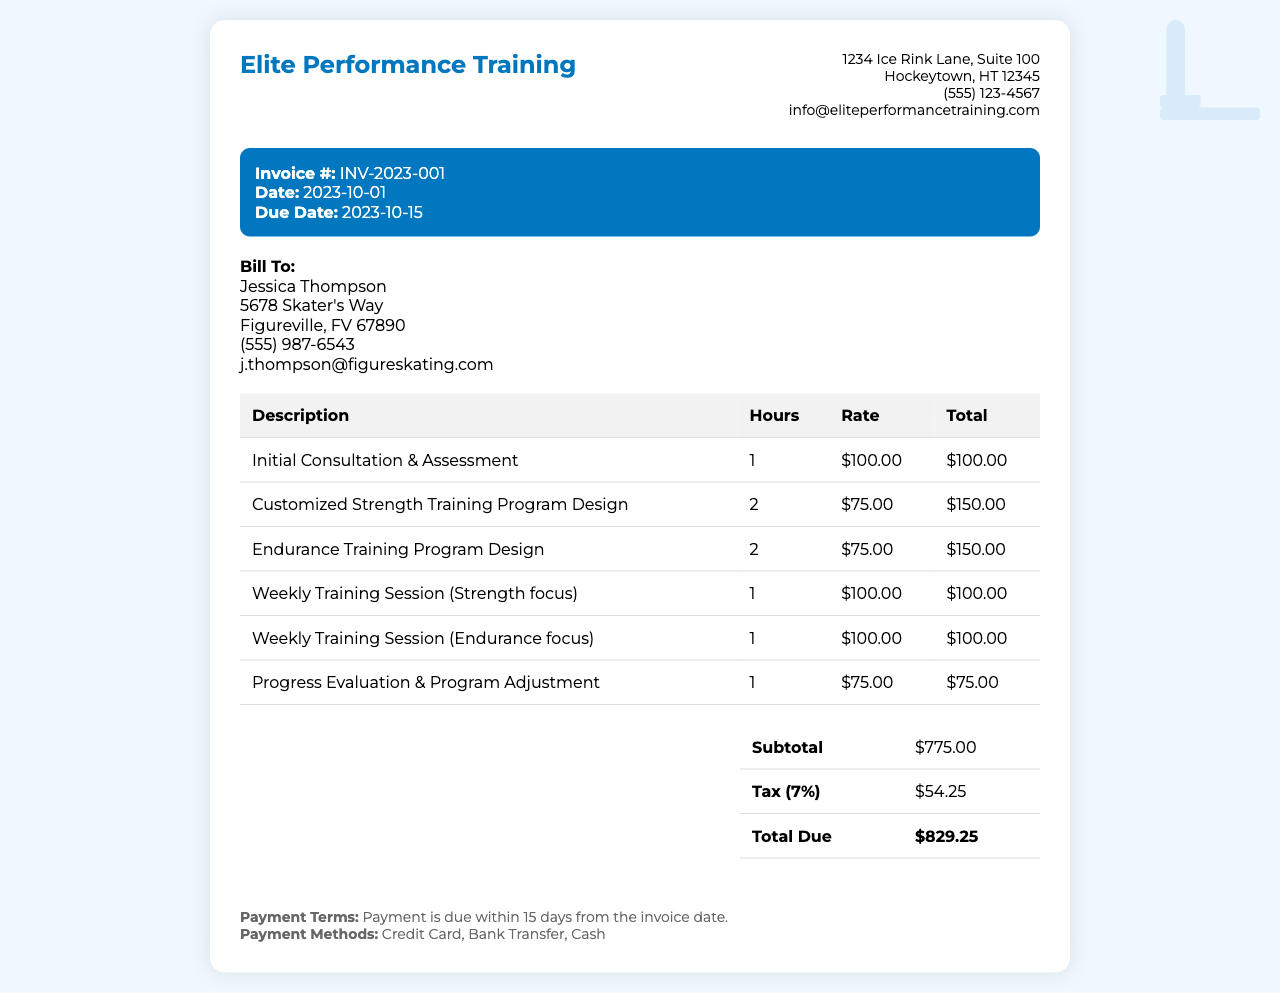What is the invoice number? The invoice number is located in the invoice details section, which identifies the specific invoice issued.
Answer: INV-2023-001 Who is the client? The client's name is provided in the client information section, which indicates who is being billed.
Answer: Jessica Thompson What is the total due amount? The total due amount is found in the summary table, which provides the final amount owed by the client including any taxes.
Answer: $829.25 What service has the highest hourly rate? The service with the highest hourly rate can be identified in the table of services based on individual rates per hour.
Answer: Initial Consultation & Assessment How many hours are billed for the Endurance Training Program Design? The number of hours for which the Endurance Training Program Design is billed can be checked in the service description table.
Answer: 2 What is the due date for this invoice? The due date is mentioned in the invoice details section, which signifies the date by which the payment should be made.
Answer: 2023-10-15 How much is the tax applied to the invoice? The tax amount is communicated in the summary table, detailing the tax calculation based on the subtotal.
Answer: $54.25 What payment methods are accepted? The accepted payment methods are provided in the payment terms section, specifying how the client can make payment.
Answer: Credit Card, Bank Transfer, Cash 